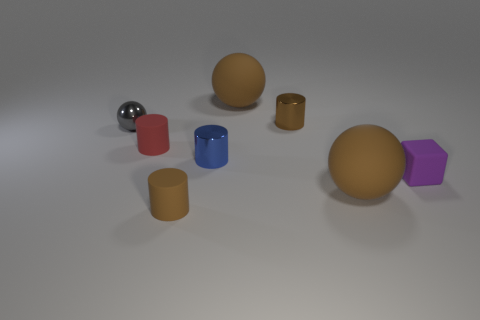Add 1 big red spheres. How many objects exist? 9 Subtract all balls. How many objects are left? 5 Subtract all metal objects. Subtract all rubber spheres. How many objects are left? 3 Add 7 purple blocks. How many purple blocks are left? 8 Add 6 purple rubber balls. How many purple rubber balls exist? 6 Subtract 0 brown cubes. How many objects are left? 8 